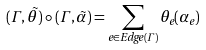<formula> <loc_0><loc_0><loc_500><loc_500>( \Gamma , \vec { \theta } ) \circ ( \Gamma , \vec { \alpha } ) = \sum _ { e \in E d g e ( \Gamma ) } \theta _ { e } ( \alpha _ { e } ) \\</formula> 